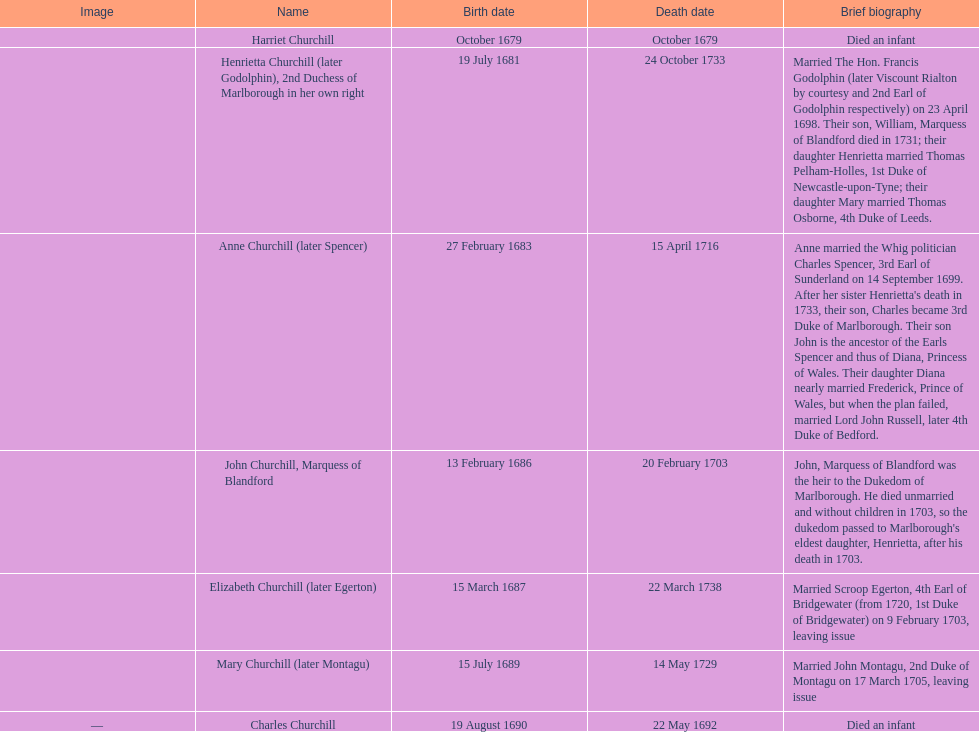How many children were born following the year 1675? 7. 